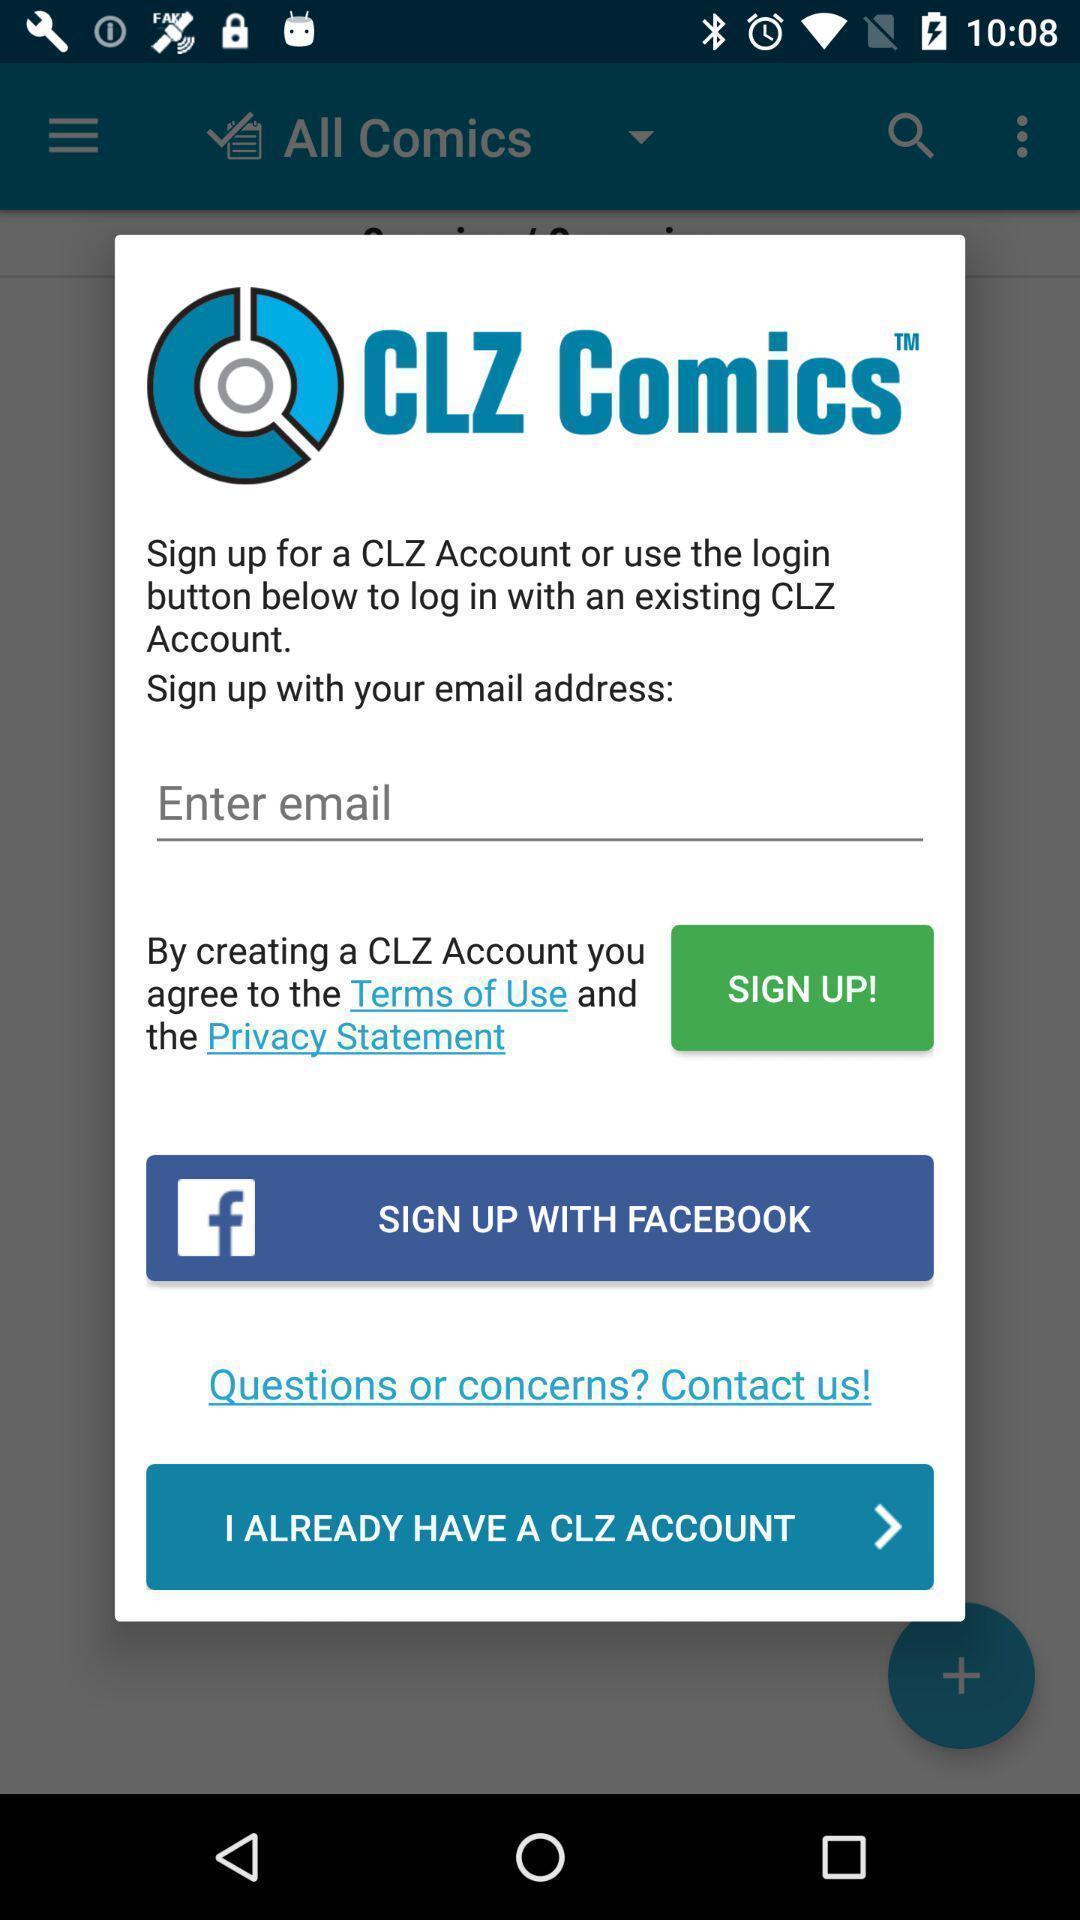Tell me what you see in this picture. Pop-up to sign up for account. 